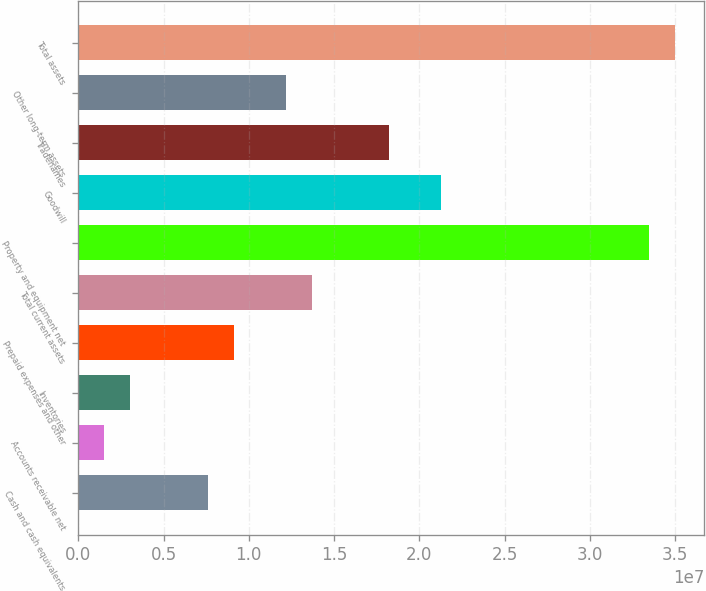<chart> <loc_0><loc_0><loc_500><loc_500><bar_chart><fcel>Cash and cash equivalents<fcel>Accounts receivable net<fcel>Inventories<fcel>Prepaid expenses and other<fcel>Total current assets<fcel>Property and equipment net<fcel>Goodwill<fcel>Tradenames<fcel>Other long-term assets<fcel>Total assets<nl><fcel>7.6031e+06<fcel>1.52081e+06<fcel>3.04138e+06<fcel>9.12368e+06<fcel>1.36854e+07<fcel>3.34529e+07<fcel>2.12883e+07<fcel>1.82471e+07<fcel>1.21648e+07<fcel>3.49734e+07<nl></chart> 